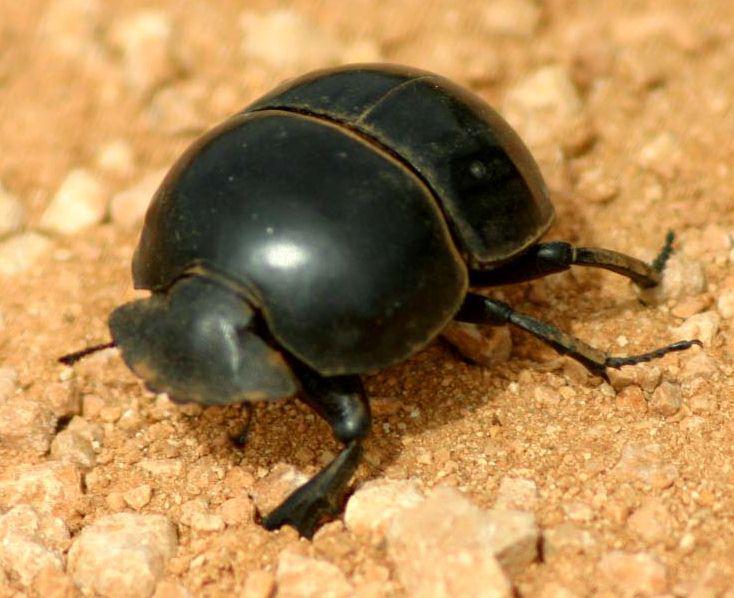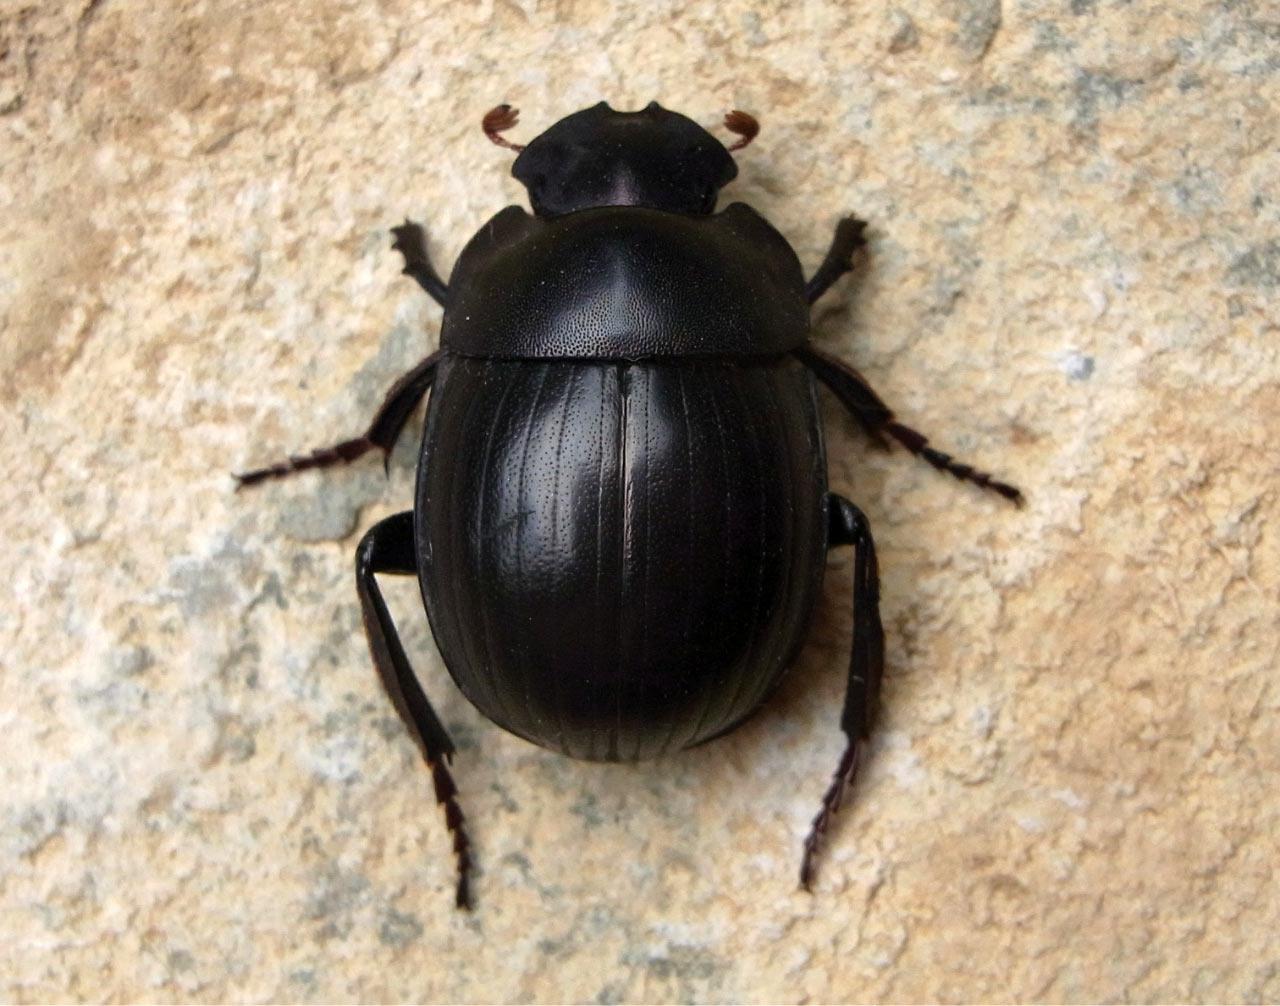The first image is the image on the left, the second image is the image on the right. Analyze the images presented: Is the assertion "There are two black beetles in total." valid? Answer yes or no. Yes. 